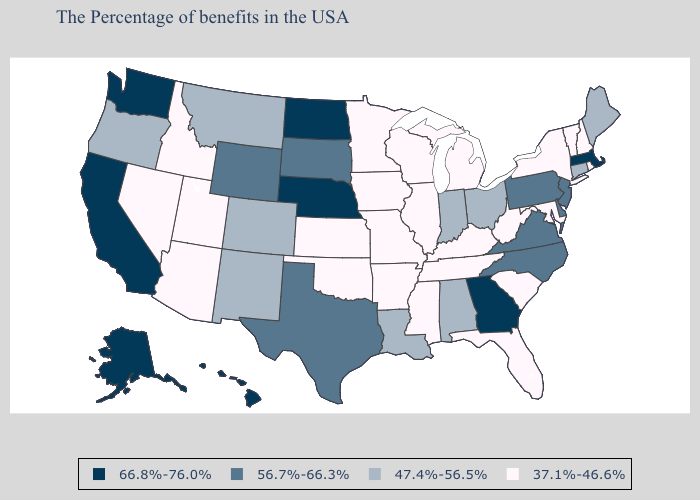What is the lowest value in the Northeast?
Concise answer only. 37.1%-46.6%. What is the lowest value in states that border Kentucky?
Quick response, please. 37.1%-46.6%. Does Arizona have a lower value than Washington?
Be succinct. Yes. Name the states that have a value in the range 56.7%-66.3%?
Short answer required. New Jersey, Delaware, Pennsylvania, Virginia, North Carolina, Texas, South Dakota, Wyoming. Does Pennsylvania have a higher value than Arizona?
Quick response, please. Yes. What is the highest value in the MidWest ?
Answer briefly. 66.8%-76.0%. Does Massachusetts have the lowest value in the Northeast?
Short answer required. No. Does Massachusetts have the highest value in the USA?
Keep it brief. Yes. Does the first symbol in the legend represent the smallest category?
Answer briefly. No. Name the states that have a value in the range 56.7%-66.3%?
Keep it brief. New Jersey, Delaware, Pennsylvania, Virginia, North Carolina, Texas, South Dakota, Wyoming. Name the states that have a value in the range 37.1%-46.6%?
Give a very brief answer. Rhode Island, New Hampshire, Vermont, New York, Maryland, South Carolina, West Virginia, Florida, Michigan, Kentucky, Tennessee, Wisconsin, Illinois, Mississippi, Missouri, Arkansas, Minnesota, Iowa, Kansas, Oklahoma, Utah, Arizona, Idaho, Nevada. Among the states that border Virginia , which have the highest value?
Give a very brief answer. North Carolina. What is the lowest value in the USA?
Give a very brief answer. 37.1%-46.6%. Does New Jersey have the same value as Delaware?
Answer briefly. Yes. 